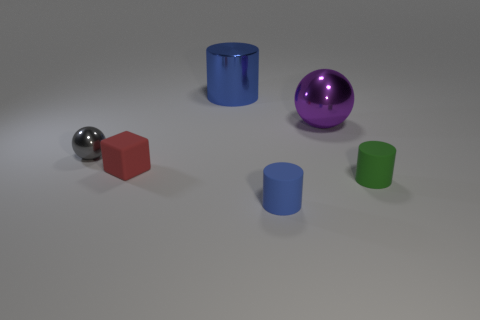There is a blue object that is right of the blue thing to the left of the tiny blue rubber cylinder; what is it made of?
Your answer should be very brief. Rubber. What material is the small thing that is the same shape as the big purple thing?
Your answer should be very brief. Metal. Is there a red rubber thing in front of the rubber object on the right side of the ball that is right of the tiny blue rubber cylinder?
Your answer should be compact. No. How many other objects are there of the same color as the metal cylinder?
Offer a terse response. 1. How many blue objects are in front of the tiny shiny object and behind the large purple shiny object?
Provide a succinct answer. 0. The tiny metal thing is what shape?
Ensure brevity in your answer.  Sphere. How many other things are there of the same material as the purple sphere?
Your answer should be very brief. 2. What color is the tiny matte object that is behind the green cylinder that is to the right of the large shiny object that is on the right side of the small blue rubber cylinder?
Make the answer very short. Red. There is a red object that is the same size as the gray metallic ball; what is its material?
Provide a short and direct response. Rubber. How many objects are either red blocks that are behind the green thing or green cylinders?
Offer a very short reply. 2. 